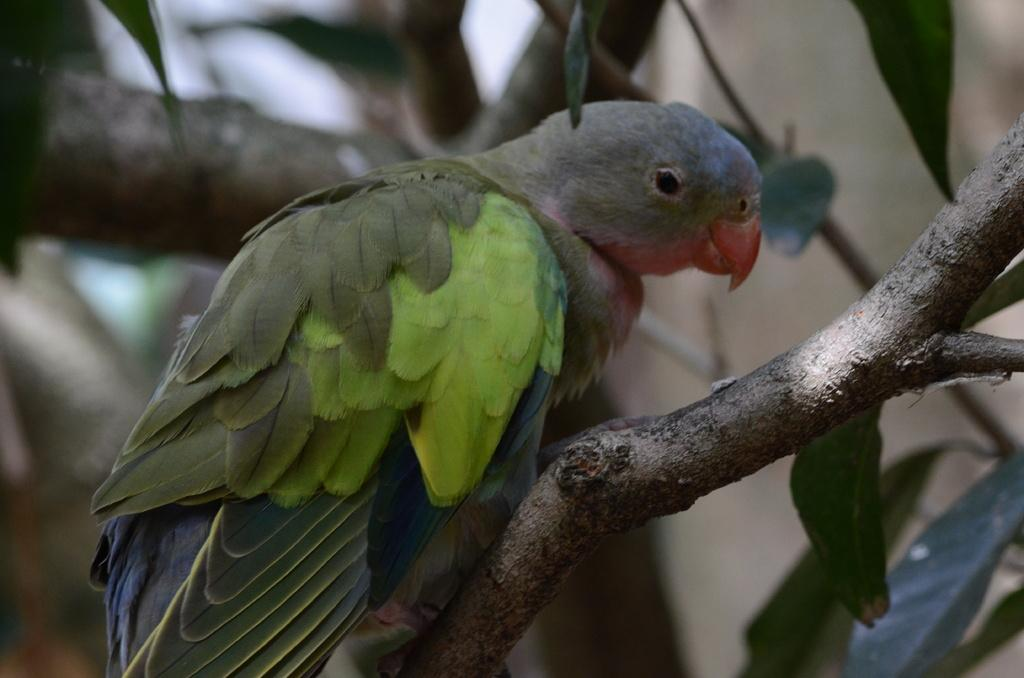What type of animal is in the image? There is a parrot in the image. What colors can be seen on the parrot? The parrot is green, orange, and black in color. Where is the parrot located in the image? The parrot is on a tree branch. Can you describe the background of the image? The background of the image is blurry. Can you tell me how many ears of corn are visible in the image? There are no ears of corn present in the image. How does the parrot use its ears to communicate in the image? Parrots do not have ears like humans; they communicate using their beaks and vocalizations. 